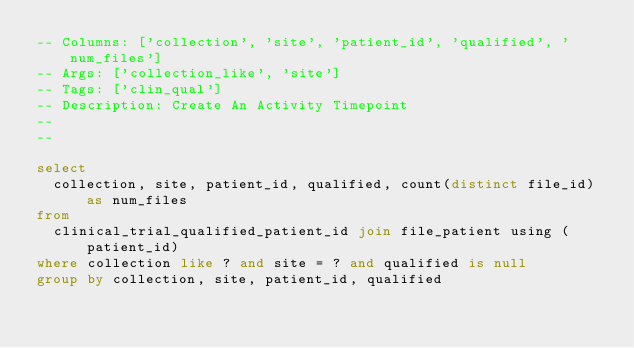<code> <loc_0><loc_0><loc_500><loc_500><_SQL_>-- Columns: ['collection', 'site', 'patient_id', 'qualified', 'num_files']
-- Args: ['collection_like', 'site']
-- Tags: ['clin_qual']
-- Description: Create An Activity Timepoint
-- 
-- 

select 
  collection, site, patient_id, qualified, count(distinct file_id) as num_files
from
  clinical_trial_qualified_patient_id join file_patient using (patient_id)
where collection like ? and site = ? and qualified is null
group by collection, site, patient_id, qualified</code> 